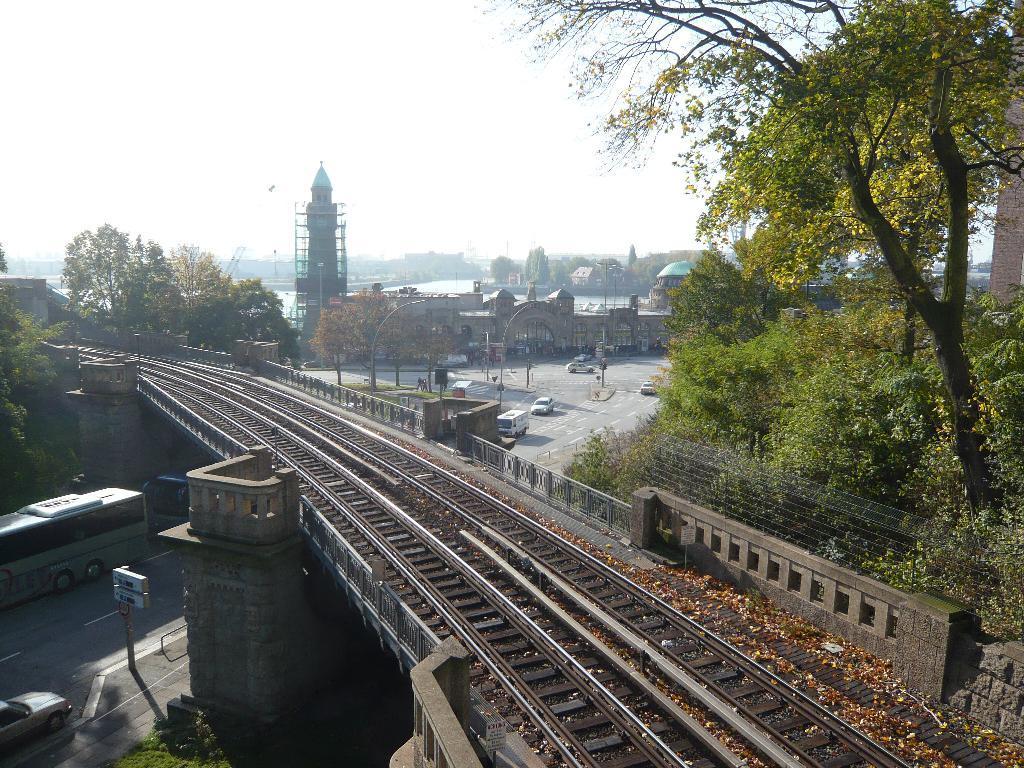In one or two sentences, can you explain what this image depicts? There is a bridge which has railway tracks on it and there are few vehicles under the bridge and there are buildings and trees in the background. 